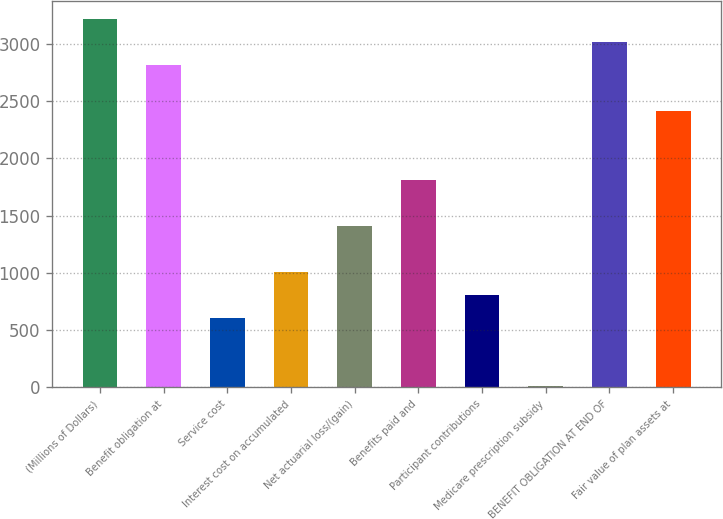<chart> <loc_0><loc_0><loc_500><loc_500><bar_chart><fcel>(Millions of Dollars)<fcel>Benefit obligation at<fcel>Service cost<fcel>Interest cost on accumulated<fcel>Net actuarial loss/(gain)<fcel>Benefits paid and<fcel>Participant contributions<fcel>Medicare prescription subsidy<fcel>BENEFIT OBLIGATION AT END OF<fcel>Fair value of plan assets at<nl><fcel>3213.4<fcel>2812.6<fcel>608.2<fcel>1009<fcel>1409.8<fcel>1810.6<fcel>808.6<fcel>7<fcel>3013<fcel>2411.8<nl></chart> 